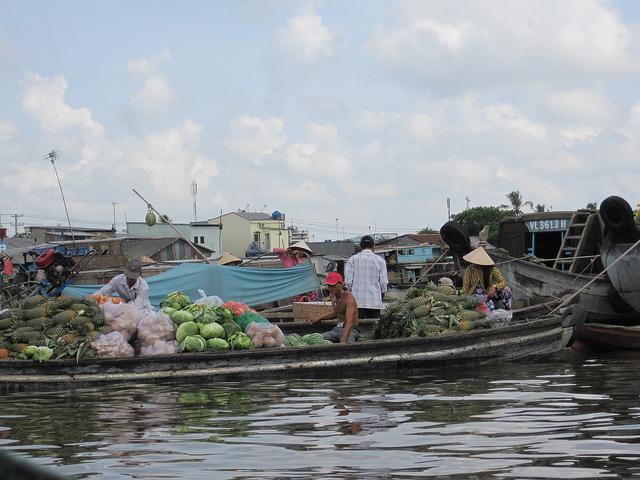How many men are pulling someone out of the water?
Concise answer only. 0. What is the man in the Red Hat sitting on?
Give a very brief answer. Boat. How many people are on the boat?
Answer briefly. 3. How many people are rowing boats?
Short answer required. 0. Is someone waving?
Short answer required. No. How many people are sitting in the boat?
Concise answer only. 2. Is it a windy day or still?
Quick response, please. Still. Is this canoe weighed down too heavily with produce?
Quick response, please. No. What kind of food is in the boat?
Be succinct. Vegetables. What is for sale?
Keep it brief. Vegetables. What is being transported?
Write a very short answer. Produce. Do these boat seat tourists?
Answer briefly. No. What type of cargo is in the back of the boat?
Answer briefly. Vegetables. Is this romantic?
Short answer required. No. What color is the basket on the boat?
Concise answer only. Brown. Are these people relaxing?
Give a very brief answer. No. What city is known for having these type of canals?
Be succinct. Venice. 